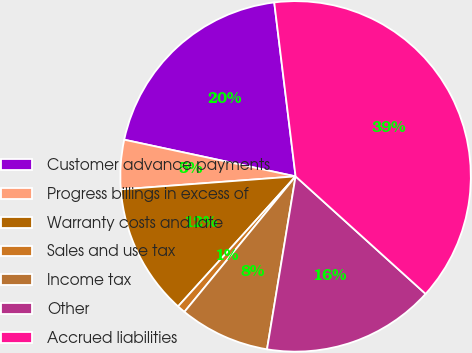<chart> <loc_0><loc_0><loc_500><loc_500><pie_chart><fcel>Customer advance payments<fcel>Progress billings in excess of<fcel>Warranty costs and late<fcel>Sales and use tax<fcel>Income tax<fcel>Other<fcel>Accrued liabilities<nl><fcel>19.7%<fcel>4.54%<fcel>12.12%<fcel>0.76%<fcel>8.33%<fcel>15.91%<fcel>38.64%<nl></chart> 